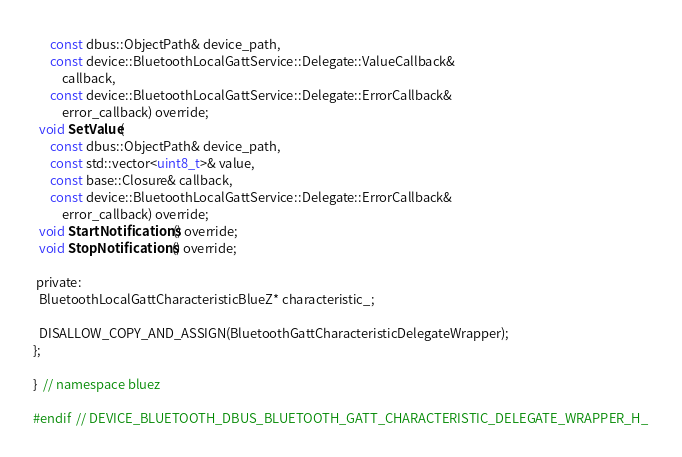Convert code to text. <code><loc_0><loc_0><loc_500><loc_500><_C_>      const dbus::ObjectPath& device_path,
      const device::BluetoothLocalGattService::Delegate::ValueCallback&
          callback,
      const device::BluetoothLocalGattService::Delegate::ErrorCallback&
          error_callback) override;
  void SetValue(
      const dbus::ObjectPath& device_path,
      const std::vector<uint8_t>& value,
      const base::Closure& callback,
      const device::BluetoothLocalGattService::Delegate::ErrorCallback&
          error_callback) override;
  void StartNotifications() override;
  void StopNotifications() override;

 private:
  BluetoothLocalGattCharacteristicBlueZ* characteristic_;

  DISALLOW_COPY_AND_ASSIGN(BluetoothGattCharacteristicDelegateWrapper);
};

}  // namespace bluez

#endif  // DEVICE_BLUETOOTH_DBUS_BLUETOOTH_GATT_CHARACTERISTIC_DELEGATE_WRAPPER_H_
</code> 